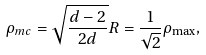<formula> <loc_0><loc_0><loc_500><loc_500>\rho _ { m c } = \sqrt { \frac { d - 2 } { 2 d } } R = \frac { 1 } { \sqrt { 2 } } \rho _ { \max } ,</formula> 